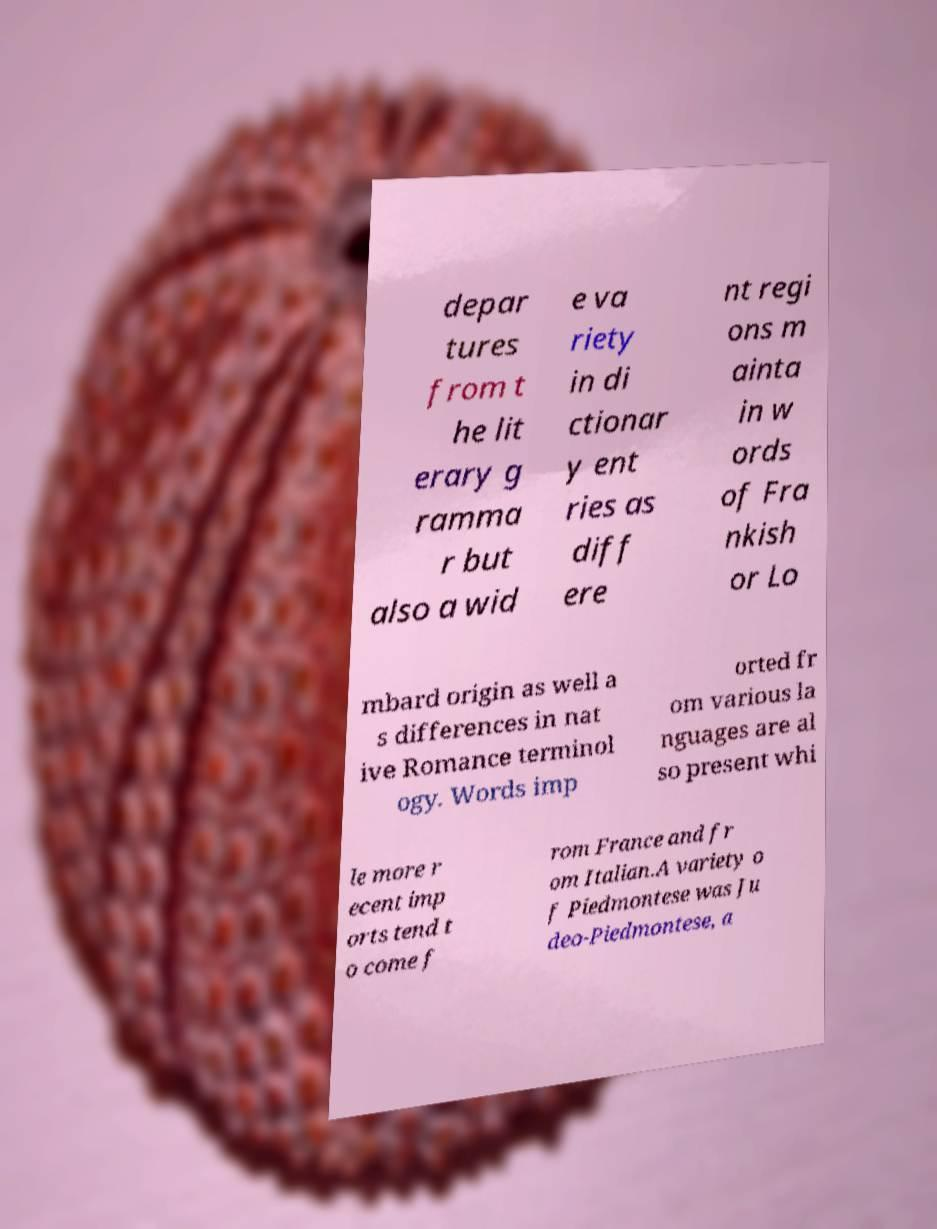Can you read and provide the text displayed in the image?This photo seems to have some interesting text. Can you extract and type it out for me? depar tures from t he lit erary g ramma r but also a wid e va riety in di ctionar y ent ries as diff ere nt regi ons m ainta in w ords of Fra nkish or Lo mbard origin as well a s differences in nat ive Romance terminol ogy. Words imp orted fr om various la nguages are al so present whi le more r ecent imp orts tend t o come f rom France and fr om Italian.A variety o f Piedmontese was Ju deo-Piedmontese, a 